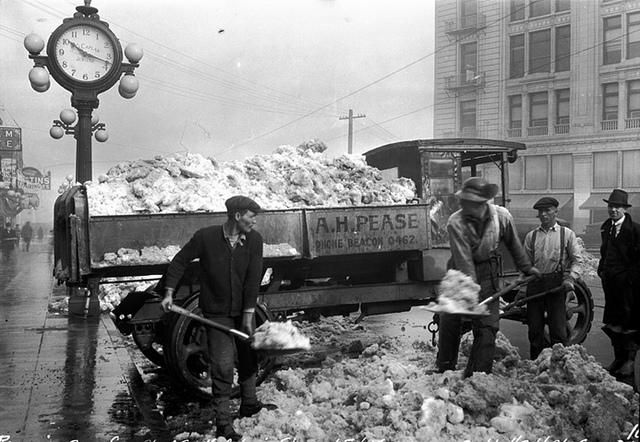What does this vehicle hold in it's rear? snow 